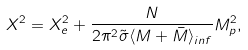Convert formula to latex. <formula><loc_0><loc_0><loc_500><loc_500>X ^ { 2 } = X _ { e } ^ { 2 } + \frac { N } { 2 \pi ^ { 2 } \tilde { \sigma } \langle M + \bar { M } \rangle _ { i n f } } M _ { p } ^ { 2 } ,</formula> 